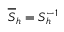<formula> <loc_0><loc_0><loc_500><loc_500>\overline { S } _ { h } = S _ { h } ^ { - 1 }</formula> 